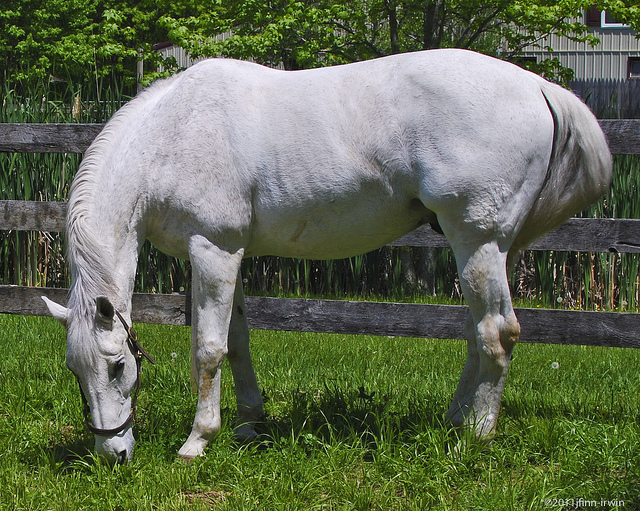If the setting of the image were changed to a winter scene, how might the horse's behavior and environment be different? If the setting of the image were changed to a winter scene, the horse might exhibit different behaviors. Instead of grazing, it might be standing still to conserve energy or seeking shelter. The grassy field would likely be covered in snow, and the horse might have a thicker winter coat to stay warm. The wooden fence might be frosted or have snow on it, and the surrounding greenery might appear barren or covered with snow. Imagine the horse could talk. What might it say about its day in this scene? If the horse could talk, it might say: 'It's a beautiful day in the pasture. The grass is lush and green, perfect for grazing. I feel relaxed and calm as I enjoy the fresh air and sunshine. The fence offers a sense of security, and the tall greenery behind it adds to the serene environment. I'm content and happy, knowing I have everything I need here.' 